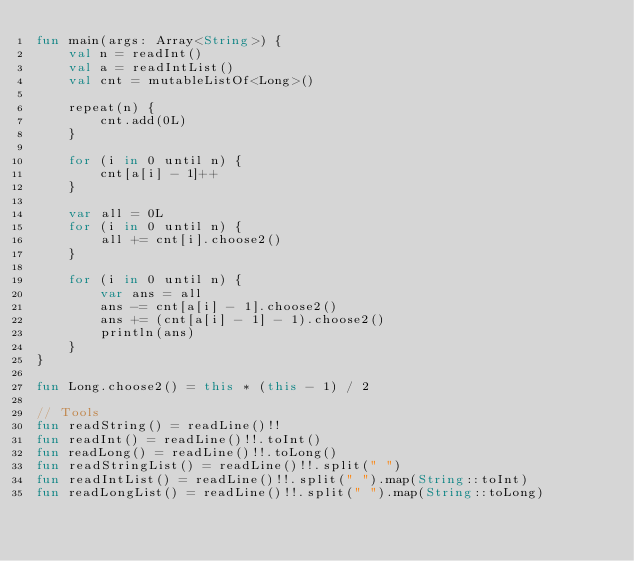<code> <loc_0><loc_0><loc_500><loc_500><_Kotlin_>fun main(args: Array<String>) {
    val n = readInt()
    val a = readIntList()
    val cnt = mutableListOf<Long>()
    
    repeat(n) {
        cnt.add(0L)
    }

    for (i in 0 until n) {
        cnt[a[i] - 1]++
    }

    var all = 0L
    for (i in 0 until n) {
        all += cnt[i].choose2()
    }

    for (i in 0 until n) {
        var ans = all
        ans -= cnt[a[i] - 1].choose2()
        ans += (cnt[a[i] - 1] - 1).choose2()
        println(ans)
    }
}

fun Long.choose2() = this * (this - 1) / 2

// Tools
fun readString() = readLine()!!
fun readInt() = readLine()!!.toInt()
fun readLong() = readLine()!!.toLong()
fun readStringList() = readLine()!!.split(" ")
fun readIntList() = readLine()!!.split(" ").map(String::toInt)
fun readLongList() = readLine()!!.split(" ").map(String::toLong)</code> 